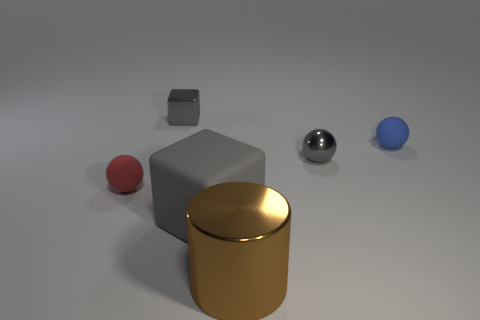Add 1 large brown objects. How many objects exist? 7 Subtract all cylinders. How many objects are left? 5 Subtract 0 purple balls. How many objects are left? 6 Subtract all tiny things. Subtract all rubber spheres. How many objects are left? 0 Add 6 tiny gray blocks. How many tiny gray blocks are left? 7 Add 5 small red objects. How many small red objects exist? 6 